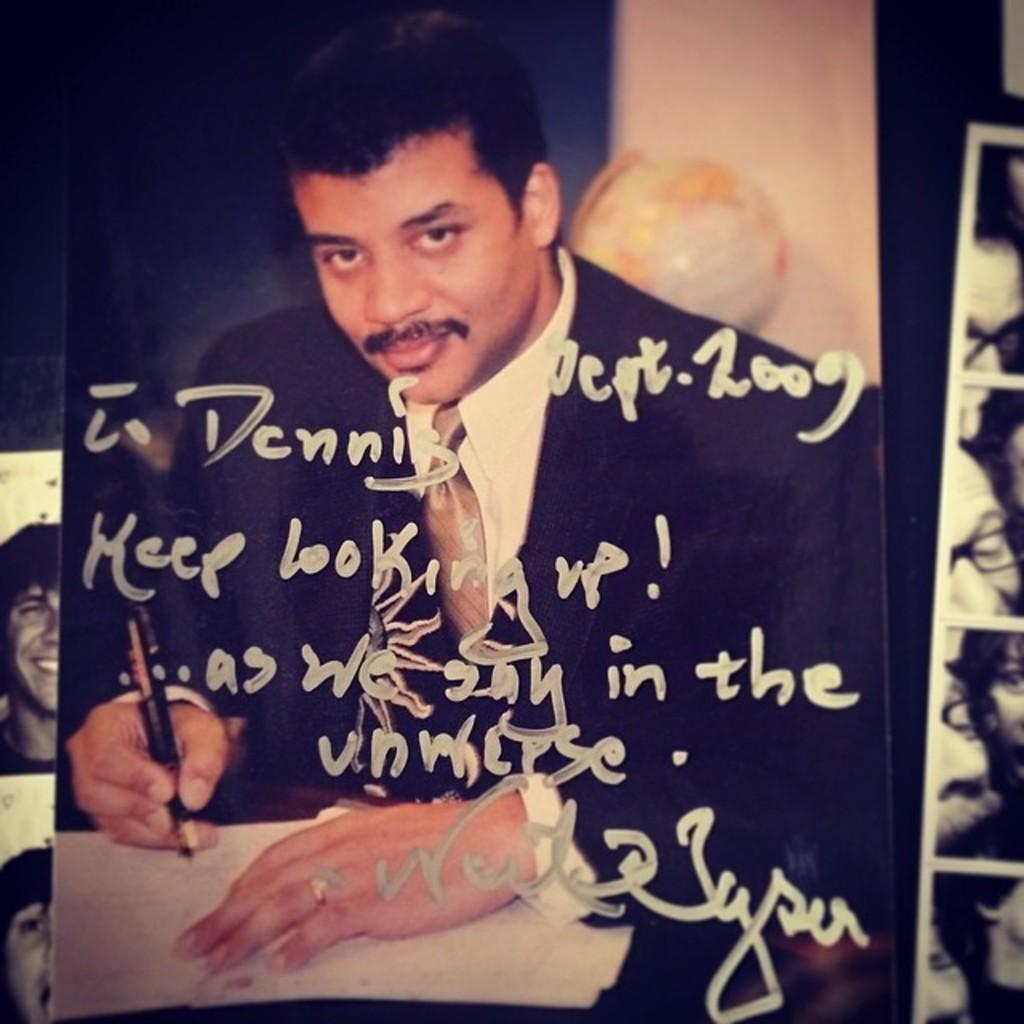What is written on the photo in the image? There is text written on a photo of a person in the image. What can be seen on the left side of the image? There are other photos on the left side of the image. What can be seen on the right side of the image? There are other photos on the right side of the image. What type of birthday experience is depicted in the image? There is no birthday experience depicted in the image; it only shows photos with text and other photos. 